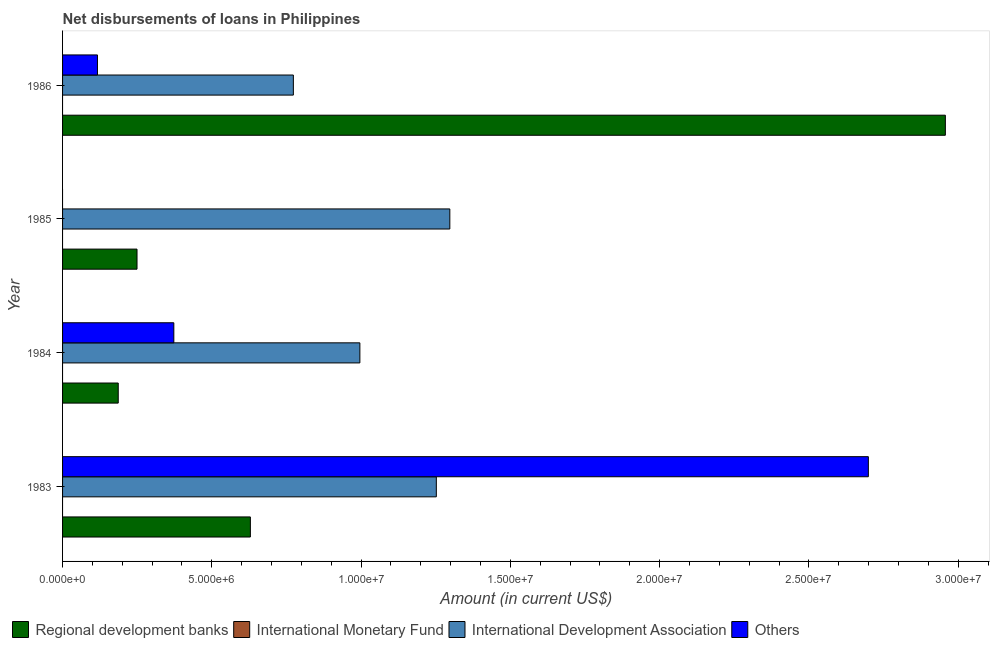How many different coloured bars are there?
Give a very brief answer. 3. Are the number of bars on each tick of the Y-axis equal?
Offer a very short reply. No. How many bars are there on the 1st tick from the bottom?
Your answer should be compact. 3. In how many cases, is the number of bars for a given year not equal to the number of legend labels?
Ensure brevity in your answer.  4. What is the amount of loan disimbursed by regional development banks in 1985?
Give a very brief answer. 2.49e+06. Across all years, what is the maximum amount of loan disimbursed by international development association?
Your answer should be very brief. 1.30e+07. In which year was the amount of loan disimbursed by international development association maximum?
Your answer should be compact. 1985. What is the total amount of loan disimbursed by regional development banks in the graph?
Your answer should be very brief. 4.02e+07. What is the difference between the amount of loan disimbursed by other organisations in 1983 and that in 1984?
Offer a very short reply. 2.33e+07. What is the difference between the amount of loan disimbursed by international development association in 1985 and the amount of loan disimbursed by regional development banks in 1986?
Provide a succinct answer. -1.66e+07. What is the average amount of loan disimbursed by international monetary fund per year?
Make the answer very short. 0. In the year 1983, what is the difference between the amount of loan disimbursed by international development association and amount of loan disimbursed by regional development banks?
Provide a succinct answer. 6.23e+06. What is the ratio of the amount of loan disimbursed by international development association in 1984 to that in 1986?
Ensure brevity in your answer.  1.29. Is the amount of loan disimbursed by international development association in 1984 less than that in 1986?
Your answer should be very brief. No. What is the difference between the highest and the second highest amount of loan disimbursed by other organisations?
Provide a short and direct response. 2.33e+07. What is the difference between the highest and the lowest amount of loan disimbursed by regional development banks?
Provide a succinct answer. 2.77e+07. Is the sum of the amount of loan disimbursed by international development association in 1983 and 1985 greater than the maximum amount of loan disimbursed by international monetary fund across all years?
Offer a very short reply. Yes. Is it the case that in every year, the sum of the amount of loan disimbursed by regional development banks and amount of loan disimbursed by other organisations is greater than the sum of amount of loan disimbursed by international development association and amount of loan disimbursed by international monetary fund?
Offer a very short reply. No. Is it the case that in every year, the sum of the amount of loan disimbursed by regional development banks and amount of loan disimbursed by international monetary fund is greater than the amount of loan disimbursed by international development association?
Your answer should be very brief. No. How many bars are there?
Provide a succinct answer. 11. Are the values on the major ticks of X-axis written in scientific E-notation?
Make the answer very short. Yes. Does the graph contain any zero values?
Ensure brevity in your answer.  Yes. Where does the legend appear in the graph?
Your answer should be very brief. Bottom left. How many legend labels are there?
Give a very brief answer. 4. What is the title of the graph?
Keep it short and to the point. Net disbursements of loans in Philippines. What is the Amount (in current US$) in Regional development banks in 1983?
Your answer should be compact. 6.29e+06. What is the Amount (in current US$) of International Monetary Fund in 1983?
Make the answer very short. 0. What is the Amount (in current US$) of International Development Association in 1983?
Provide a short and direct response. 1.25e+07. What is the Amount (in current US$) of Others in 1983?
Provide a short and direct response. 2.70e+07. What is the Amount (in current US$) in Regional development banks in 1984?
Give a very brief answer. 1.86e+06. What is the Amount (in current US$) in International Monetary Fund in 1984?
Provide a short and direct response. 0. What is the Amount (in current US$) of International Development Association in 1984?
Your answer should be very brief. 9.96e+06. What is the Amount (in current US$) in Others in 1984?
Provide a succinct answer. 3.73e+06. What is the Amount (in current US$) in Regional development banks in 1985?
Offer a terse response. 2.49e+06. What is the Amount (in current US$) in International Monetary Fund in 1985?
Your answer should be compact. 0. What is the Amount (in current US$) in International Development Association in 1985?
Offer a terse response. 1.30e+07. What is the Amount (in current US$) of Regional development banks in 1986?
Offer a very short reply. 2.96e+07. What is the Amount (in current US$) in International Monetary Fund in 1986?
Provide a short and direct response. 0. What is the Amount (in current US$) in International Development Association in 1986?
Your answer should be very brief. 7.73e+06. What is the Amount (in current US$) of Others in 1986?
Keep it short and to the point. 1.17e+06. Across all years, what is the maximum Amount (in current US$) of Regional development banks?
Your response must be concise. 2.96e+07. Across all years, what is the maximum Amount (in current US$) of International Development Association?
Keep it short and to the point. 1.30e+07. Across all years, what is the maximum Amount (in current US$) of Others?
Provide a succinct answer. 2.70e+07. Across all years, what is the minimum Amount (in current US$) in Regional development banks?
Your answer should be very brief. 1.86e+06. Across all years, what is the minimum Amount (in current US$) in International Development Association?
Your response must be concise. 7.73e+06. What is the total Amount (in current US$) in Regional development banks in the graph?
Offer a terse response. 4.02e+07. What is the total Amount (in current US$) of International Monetary Fund in the graph?
Your answer should be very brief. 0. What is the total Amount (in current US$) in International Development Association in the graph?
Ensure brevity in your answer.  4.32e+07. What is the total Amount (in current US$) in Others in the graph?
Your response must be concise. 3.19e+07. What is the difference between the Amount (in current US$) of Regional development banks in 1983 and that in 1984?
Keep it short and to the point. 4.43e+06. What is the difference between the Amount (in current US$) of International Development Association in 1983 and that in 1984?
Ensure brevity in your answer.  2.56e+06. What is the difference between the Amount (in current US$) of Others in 1983 and that in 1984?
Make the answer very short. 2.33e+07. What is the difference between the Amount (in current US$) in Regional development banks in 1983 and that in 1985?
Your answer should be compact. 3.80e+06. What is the difference between the Amount (in current US$) in International Development Association in 1983 and that in 1985?
Your response must be concise. -4.52e+05. What is the difference between the Amount (in current US$) of Regional development banks in 1983 and that in 1986?
Provide a short and direct response. -2.33e+07. What is the difference between the Amount (in current US$) in International Development Association in 1983 and that in 1986?
Offer a terse response. 4.79e+06. What is the difference between the Amount (in current US$) in Others in 1983 and that in 1986?
Provide a short and direct response. 2.58e+07. What is the difference between the Amount (in current US$) in Regional development banks in 1984 and that in 1985?
Make the answer very short. -6.29e+05. What is the difference between the Amount (in current US$) of International Development Association in 1984 and that in 1985?
Offer a very short reply. -3.01e+06. What is the difference between the Amount (in current US$) of Regional development banks in 1984 and that in 1986?
Offer a terse response. -2.77e+07. What is the difference between the Amount (in current US$) of International Development Association in 1984 and that in 1986?
Offer a very short reply. 2.23e+06. What is the difference between the Amount (in current US$) in Others in 1984 and that in 1986?
Your answer should be very brief. 2.56e+06. What is the difference between the Amount (in current US$) of Regional development banks in 1985 and that in 1986?
Your answer should be very brief. -2.71e+07. What is the difference between the Amount (in current US$) in International Development Association in 1985 and that in 1986?
Offer a terse response. 5.24e+06. What is the difference between the Amount (in current US$) in Regional development banks in 1983 and the Amount (in current US$) in International Development Association in 1984?
Give a very brief answer. -3.67e+06. What is the difference between the Amount (in current US$) of Regional development banks in 1983 and the Amount (in current US$) of Others in 1984?
Make the answer very short. 2.56e+06. What is the difference between the Amount (in current US$) of International Development Association in 1983 and the Amount (in current US$) of Others in 1984?
Provide a succinct answer. 8.79e+06. What is the difference between the Amount (in current US$) in Regional development banks in 1983 and the Amount (in current US$) in International Development Association in 1985?
Provide a short and direct response. -6.68e+06. What is the difference between the Amount (in current US$) of Regional development banks in 1983 and the Amount (in current US$) of International Development Association in 1986?
Offer a very short reply. -1.44e+06. What is the difference between the Amount (in current US$) of Regional development banks in 1983 and the Amount (in current US$) of Others in 1986?
Give a very brief answer. 5.12e+06. What is the difference between the Amount (in current US$) of International Development Association in 1983 and the Amount (in current US$) of Others in 1986?
Ensure brevity in your answer.  1.14e+07. What is the difference between the Amount (in current US$) in Regional development banks in 1984 and the Amount (in current US$) in International Development Association in 1985?
Make the answer very short. -1.11e+07. What is the difference between the Amount (in current US$) in Regional development banks in 1984 and the Amount (in current US$) in International Development Association in 1986?
Your answer should be compact. -5.87e+06. What is the difference between the Amount (in current US$) in Regional development banks in 1984 and the Amount (in current US$) in Others in 1986?
Provide a short and direct response. 6.96e+05. What is the difference between the Amount (in current US$) of International Development Association in 1984 and the Amount (in current US$) of Others in 1986?
Offer a very short reply. 8.79e+06. What is the difference between the Amount (in current US$) in Regional development banks in 1985 and the Amount (in current US$) in International Development Association in 1986?
Your answer should be compact. -5.24e+06. What is the difference between the Amount (in current US$) in Regional development banks in 1985 and the Amount (in current US$) in Others in 1986?
Make the answer very short. 1.32e+06. What is the difference between the Amount (in current US$) in International Development Association in 1985 and the Amount (in current US$) in Others in 1986?
Provide a short and direct response. 1.18e+07. What is the average Amount (in current US$) in Regional development banks per year?
Your response must be concise. 1.01e+07. What is the average Amount (in current US$) in International Monetary Fund per year?
Your answer should be very brief. 0. What is the average Amount (in current US$) in International Development Association per year?
Offer a terse response. 1.08e+07. What is the average Amount (in current US$) of Others per year?
Your response must be concise. 7.97e+06. In the year 1983, what is the difference between the Amount (in current US$) in Regional development banks and Amount (in current US$) in International Development Association?
Keep it short and to the point. -6.23e+06. In the year 1983, what is the difference between the Amount (in current US$) of Regional development banks and Amount (in current US$) of Others?
Make the answer very short. -2.07e+07. In the year 1983, what is the difference between the Amount (in current US$) of International Development Association and Amount (in current US$) of Others?
Offer a very short reply. -1.45e+07. In the year 1984, what is the difference between the Amount (in current US$) in Regional development banks and Amount (in current US$) in International Development Association?
Keep it short and to the point. -8.09e+06. In the year 1984, what is the difference between the Amount (in current US$) in Regional development banks and Amount (in current US$) in Others?
Your answer should be very brief. -1.86e+06. In the year 1984, what is the difference between the Amount (in current US$) in International Development Association and Amount (in current US$) in Others?
Your answer should be compact. 6.23e+06. In the year 1985, what is the difference between the Amount (in current US$) in Regional development banks and Amount (in current US$) in International Development Association?
Keep it short and to the point. -1.05e+07. In the year 1986, what is the difference between the Amount (in current US$) of Regional development banks and Amount (in current US$) of International Development Association?
Provide a short and direct response. 2.18e+07. In the year 1986, what is the difference between the Amount (in current US$) of Regional development banks and Amount (in current US$) of Others?
Your answer should be very brief. 2.84e+07. In the year 1986, what is the difference between the Amount (in current US$) of International Development Association and Amount (in current US$) of Others?
Make the answer very short. 6.56e+06. What is the ratio of the Amount (in current US$) of Regional development banks in 1983 to that in 1984?
Give a very brief answer. 3.37. What is the ratio of the Amount (in current US$) in International Development Association in 1983 to that in 1984?
Provide a short and direct response. 1.26. What is the ratio of the Amount (in current US$) in Others in 1983 to that in 1984?
Provide a short and direct response. 7.24. What is the ratio of the Amount (in current US$) of Regional development banks in 1983 to that in 1985?
Provide a succinct answer. 2.52. What is the ratio of the Amount (in current US$) in International Development Association in 1983 to that in 1985?
Your answer should be very brief. 0.97. What is the ratio of the Amount (in current US$) of Regional development banks in 1983 to that in 1986?
Your answer should be very brief. 0.21. What is the ratio of the Amount (in current US$) in International Development Association in 1983 to that in 1986?
Make the answer very short. 1.62. What is the ratio of the Amount (in current US$) of Others in 1983 to that in 1986?
Provide a short and direct response. 23.09. What is the ratio of the Amount (in current US$) of Regional development banks in 1984 to that in 1985?
Your answer should be very brief. 0.75. What is the ratio of the Amount (in current US$) in International Development Association in 1984 to that in 1985?
Offer a very short reply. 0.77. What is the ratio of the Amount (in current US$) of Regional development banks in 1984 to that in 1986?
Provide a succinct answer. 0.06. What is the ratio of the Amount (in current US$) in International Development Association in 1984 to that in 1986?
Make the answer very short. 1.29. What is the ratio of the Amount (in current US$) in Others in 1984 to that in 1986?
Keep it short and to the point. 3.19. What is the ratio of the Amount (in current US$) of Regional development banks in 1985 to that in 1986?
Keep it short and to the point. 0.08. What is the ratio of the Amount (in current US$) of International Development Association in 1985 to that in 1986?
Ensure brevity in your answer.  1.68. What is the difference between the highest and the second highest Amount (in current US$) in Regional development banks?
Ensure brevity in your answer.  2.33e+07. What is the difference between the highest and the second highest Amount (in current US$) of International Development Association?
Your answer should be very brief. 4.52e+05. What is the difference between the highest and the second highest Amount (in current US$) of Others?
Keep it short and to the point. 2.33e+07. What is the difference between the highest and the lowest Amount (in current US$) of Regional development banks?
Offer a very short reply. 2.77e+07. What is the difference between the highest and the lowest Amount (in current US$) of International Development Association?
Ensure brevity in your answer.  5.24e+06. What is the difference between the highest and the lowest Amount (in current US$) in Others?
Ensure brevity in your answer.  2.70e+07. 